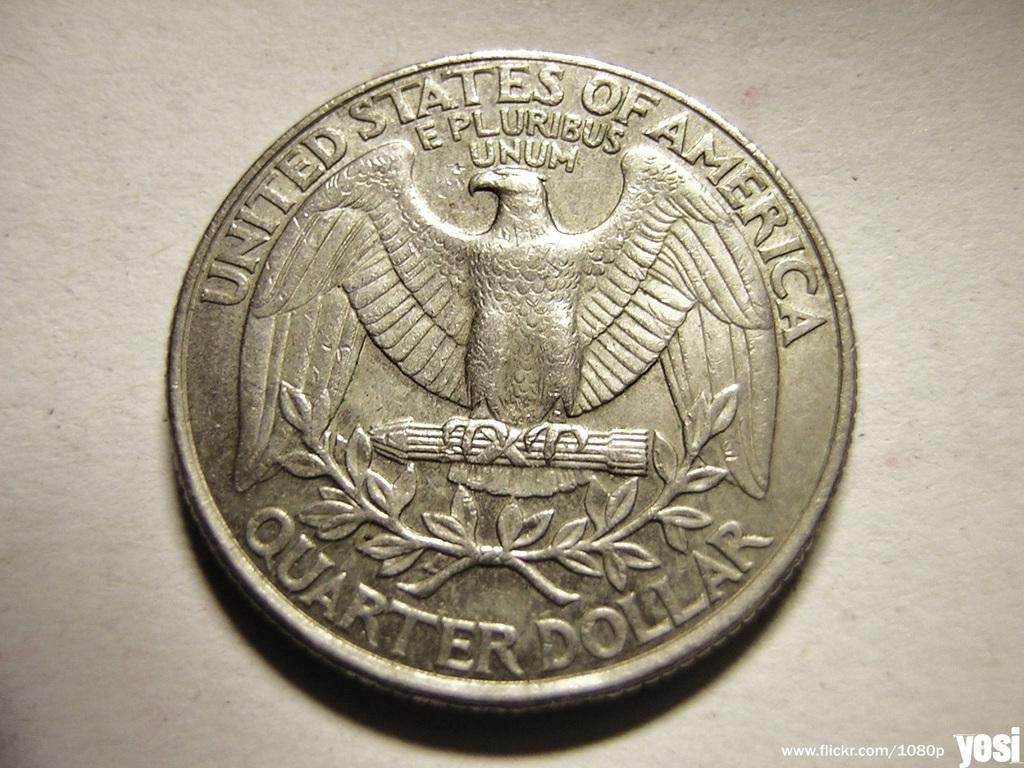<image>
Render a clear and concise summary of the photo. A Quarter Dollar coin has the image of an eagle on it. 